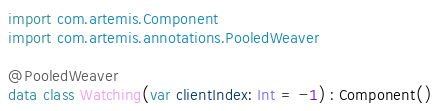Convert code to text. <code><loc_0><loc_0><loc_500><loc_500><_Kotlin_>
import com.artemis.Component
import com.artemis.annotations.PooledWeaver

@PooledWeaver
data class Watching(var clientIndex: Int = -1) : Component()</code> 